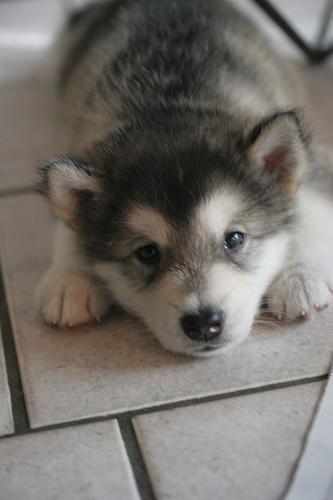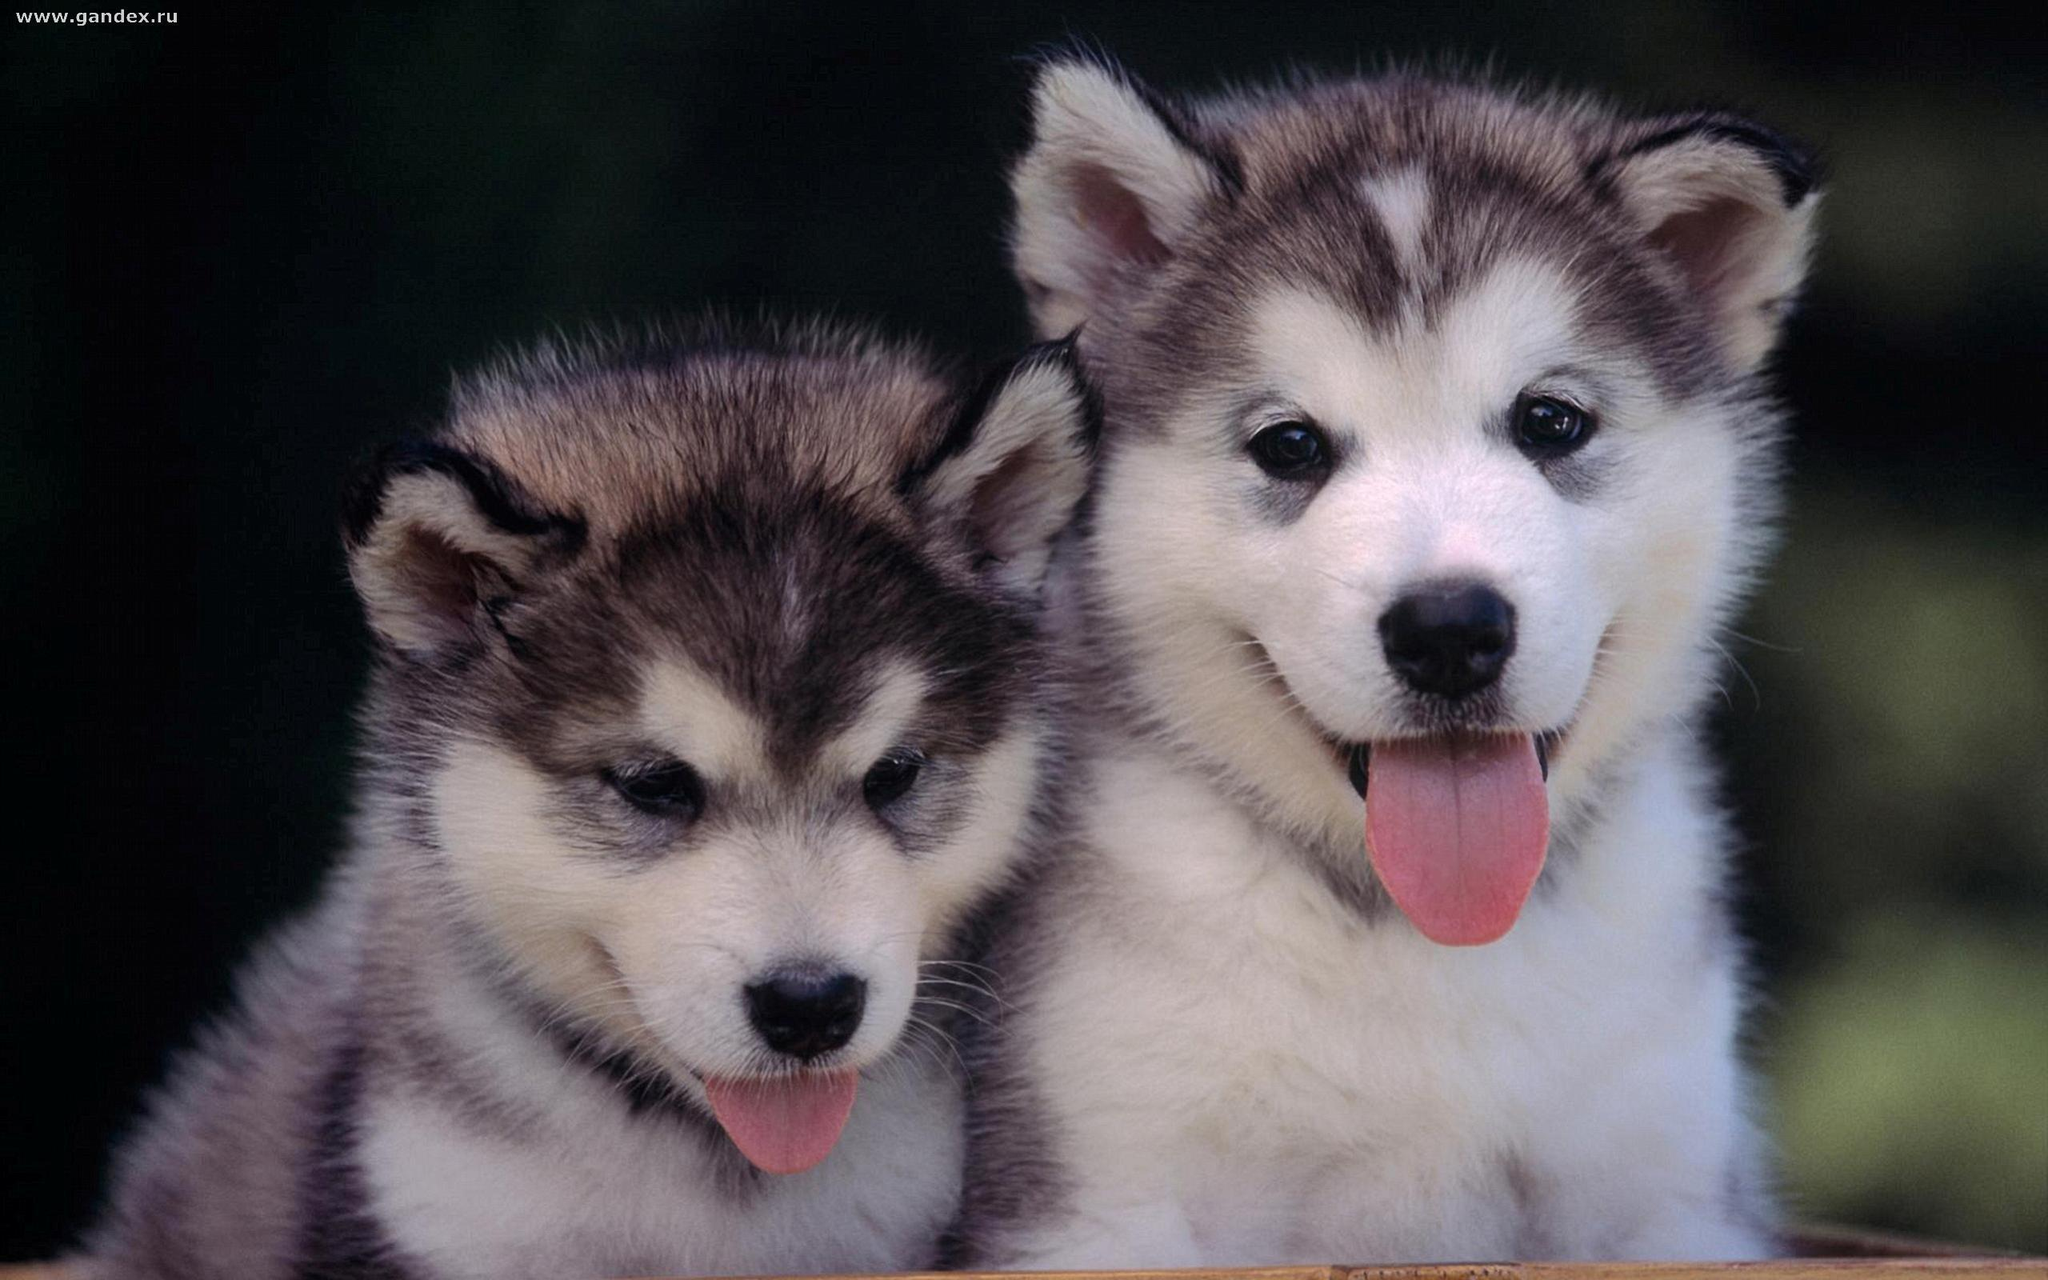The first image is the image on the left, the second image is the image on the right. Considering the images on both sides, is "Exactly two dogs have their tongues out." valid? Answer yes or no. Yes. 